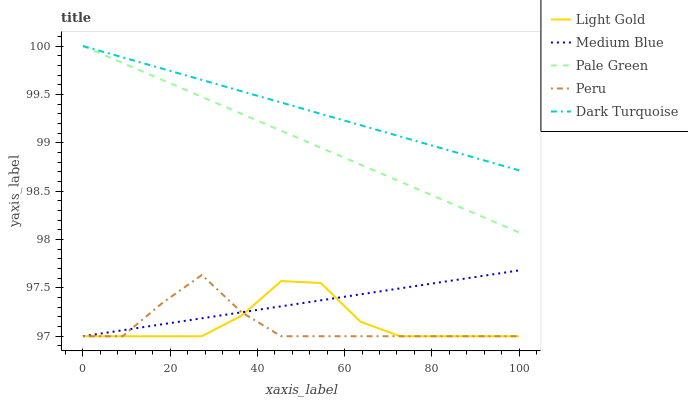Does Peru have the minimum area under the curve?
Answer yes or no. Yes. Does Dark Turquoise have the maximum area under the curve?
Answer yes or no. Yes. Does Pale Green have the minimum area under the curve?
Answer yes or no. No. Does Pale Green have the maximum area under the curve?
Answer yes or no. No. Is Medium Blue the smoothest?
Answer yes or no. Yes. Is Light Gold the roughest?
Answer yes or no. Yes. Is Pale Green the smoothest?
Answer yes or no. No. Is Pale Green the roughest?
Answer yes or no. No. Does Medium Blue have the lowest value?
Answer yes or no. Yes. Does Pale Green have the lowest value?
Answer yes or no. No. Does Dark Turquoise have the highest value?
Answer yes or no. Yes. Does Light Gold have the highest value?
Answer yes or no. No. Is Peru less than Pale Green?
Answer yes or no. Yes. Is Dark Turquoise greater than Peru?
Answer yes or no. Yes. Does Medium Blue intersect Peru?
Answer yes or no. Yes. Is Medium Blue less than Peru?
Answer yes or no. No. Is Medium Blue greater than Peru?
Answer yes or no. No. Does Peru intersect Pale Green?
Answer yes or no. No. 